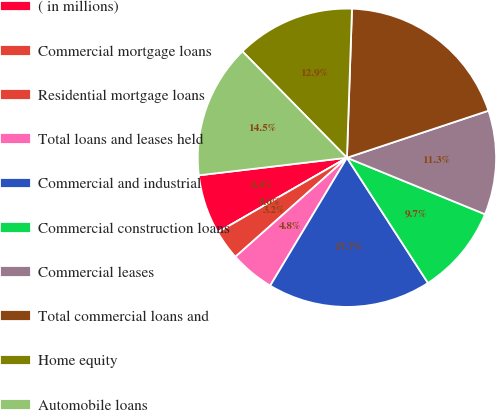Convert chart to OTSL. <chart><loc_0><loc_0><loc_500><loc_500><pie_chart><fcel>( in millions)<fcel>Commercial mortgage loans<fcel>Residential mortgage loans<fcel>Total loans and leases held<fcel>Commercial and industrial<fcel>Commercial construction loans<fcel>Commercial leases<fcel>Total commercial loans and<fcel>Home equity<fcel>Automobile loans<nl><fcel>6.45%<fcel>0.0%<fcel>3.23%<fcel>4.84%<fcel>17.74%<fcel>9.68%<fcel>11.29%<fcel>19.35%<fcel>12.9%<fcel>14.52%<nl></chart> 